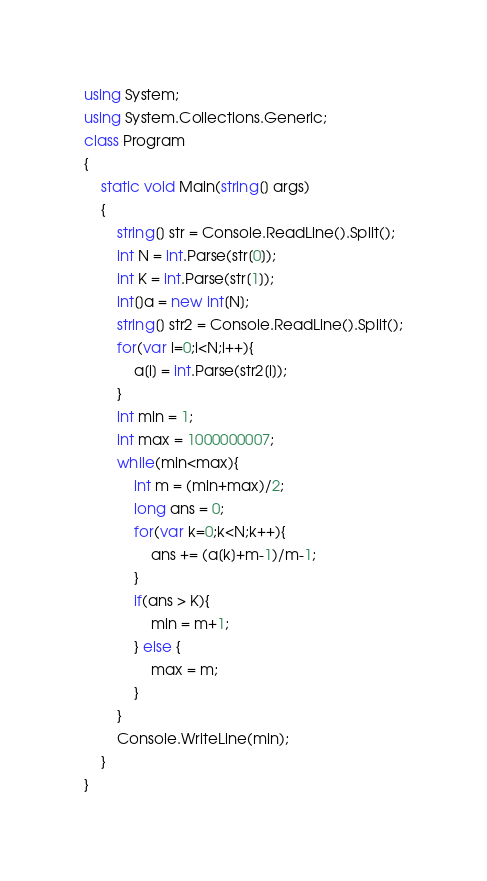Convert code to text. <code><loc_0><loc_0><loc_500><loc_500><_C#_>using System;
using System.Collections.Generic;
class Program
{
	static void Main(string[] args)
	{
		string[] str = Console.ReadLine().Split();
		int N = int.Parse(str[0]);
		int K = int.Parse(str[1]);
		int[]a = new int[N];
		string[] str2 = Console.ReadLine().Split();
		for(var i=0;i<N;i++){
			a[i] = int.Parse(str2[i]);
		}
		int min = 1;
		int max = 1000000007;
		while(min<max){
			int m = (min+max)/2;
			long ans = 0;
			for(var k=0;k<N;k++){
				ans += (a[k]+m-1)/m-1;
			}
			if(ans > K){
				min = m+1;
			} else {
				max = m;
			}
		}
		Console.WriteLine(min);
	}
}</code> 